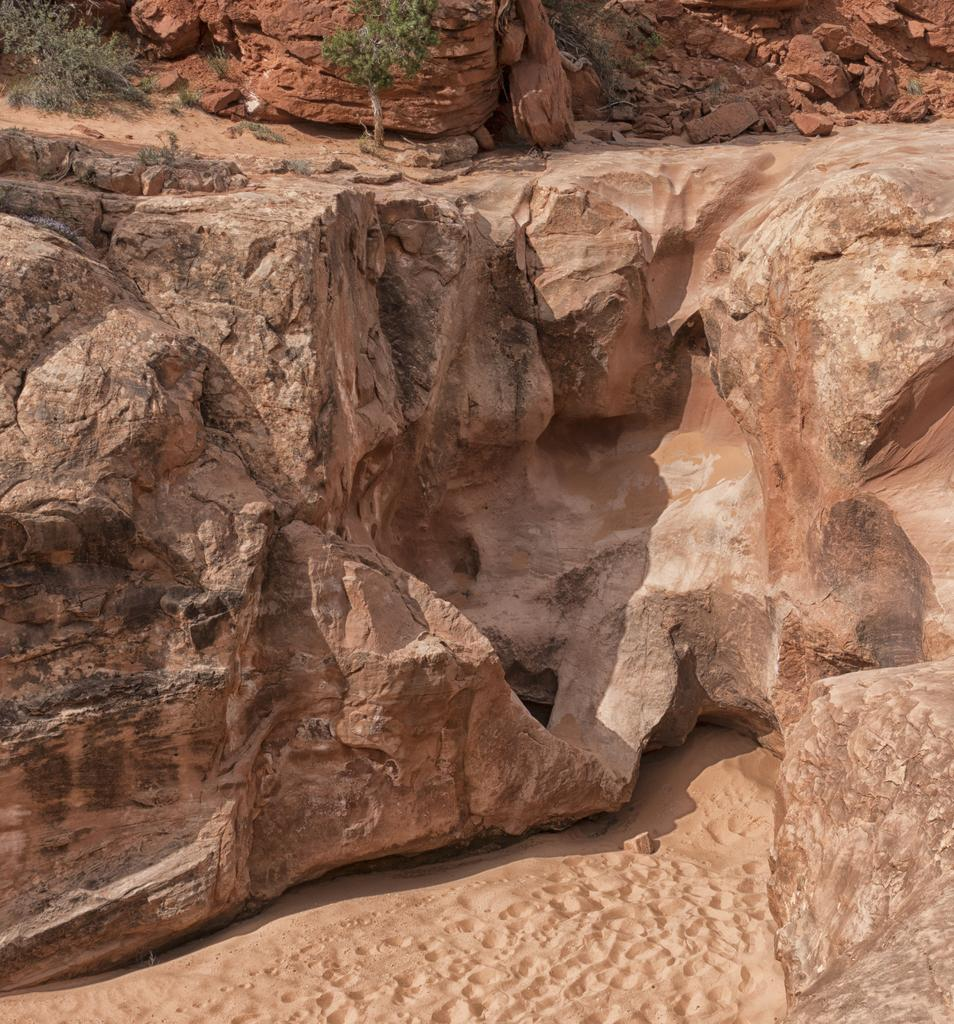What geographical feature is the main subject of the picture? There is a mountain in the picture. What can be found on the mountain? The mountain has plants and rocks. What type of surface is visible on the floor in the picture? There is sand on the floor in the picture. What type of cord is hanging from the mountain in the picture? There is no cord visible in the picture; it only features a mountain with plants and rocks, and sand on the floor. 